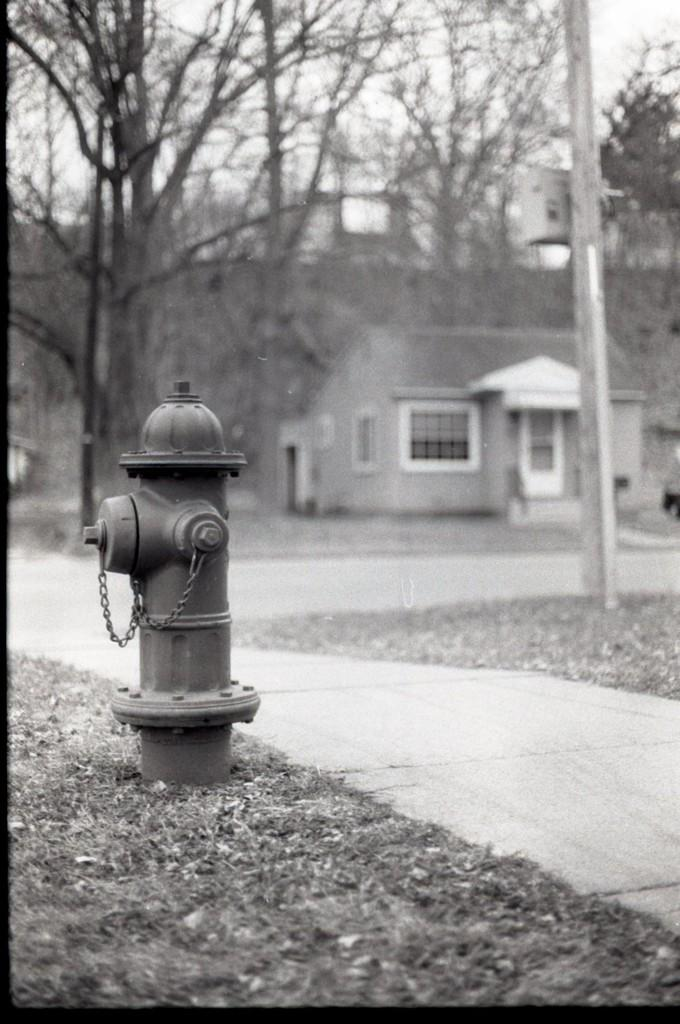What is the color scheme of the image? The image is black and white. What object can be seen on the left side of the image? There is a fire hydrant on the left side of the image. Where is the fire hydrant located? The fire hydrant is located in a garden. What can be seen in the background of the image? There is a home in the background of the image. What type of vegetation is present in front of the home? Trees are present in front of the home. Where is the meeting with your friend taking place in the image? There is no meeting or friend present in the image; it features a fire hydrant in a garden with a home and trees in the background. What type of field can be seen in the image? There is no field present in the image; it features a fire hydrant in a garden with a home and trees in the background. 